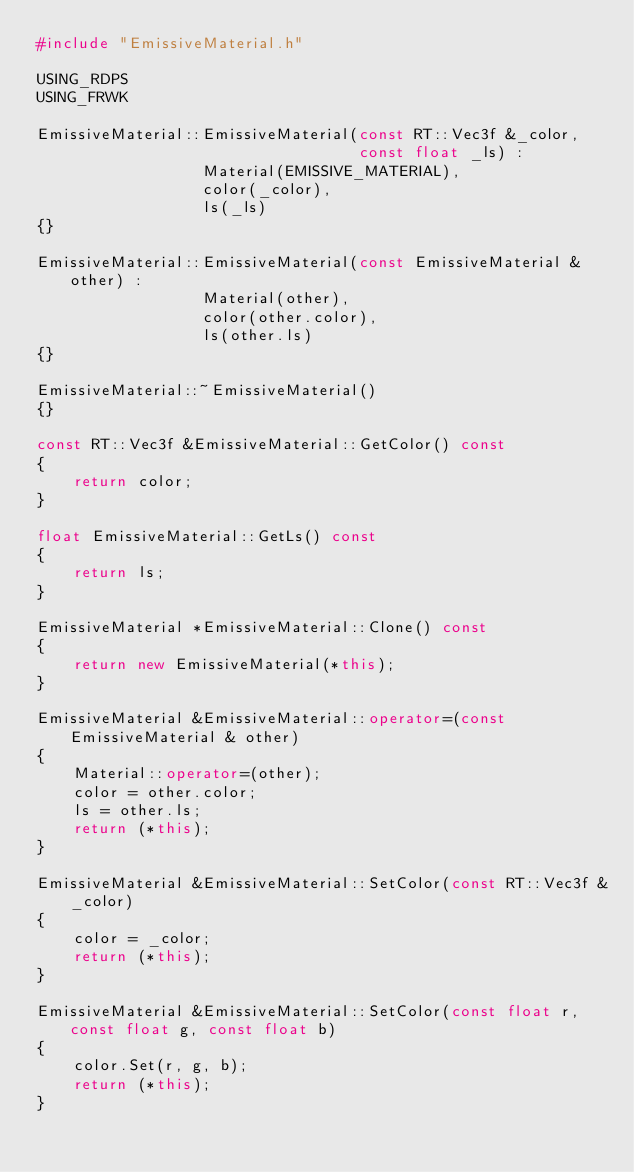<code> <loc_0><loc_0><loc_500><loc_500><_C++_>#include "EmissiveMaterial.h"

USING_RDPS
USING_FRWK

EmissiveMaterial::EmissiveMaterial(const RT::Vec3f &_color, 
								   const float _ls) :
				  Material(EMISSIVE_MATERIAL),
				  color(_color),
				  ls(_ls)
{}

EmissiveMaterial::EmissiveMaterial(const EmissiveMaterial &other) :
				  Material(other),
				  color(other.color),
				  ls(other.ls)
{}

EmissiveMaterial::~EmissiveMaterial()
{}

const RT::Vec3f &EmissiveMaterial::GetColor() const
{
	return color;
}

float EmissiveMaterial::GetLs() const
{
	return ls;
}

EmissiveMaterial *EmissiveMaterial::Clone() const
{
	return new EmissiveMaterial(*this);
}

EmissiveMaterial &EmissiveMaterial::operator=(const EmissiveMaterial & other)
{
	Material::operator=(other);
	color = other.color;
	ls = other.ls;
	return (*this);
}

EmissiveMaterial &EmissiveMaterial::SetColor(const RT::Vec3f &_color)
{
	color = _color;
	return (*this);
}

EmissiveMaterial &EmissiveMaterial::SetColor(const float r, const float g, const float b)
{
	color.Set(r, g, b);
	return (*this);
}
</code> 